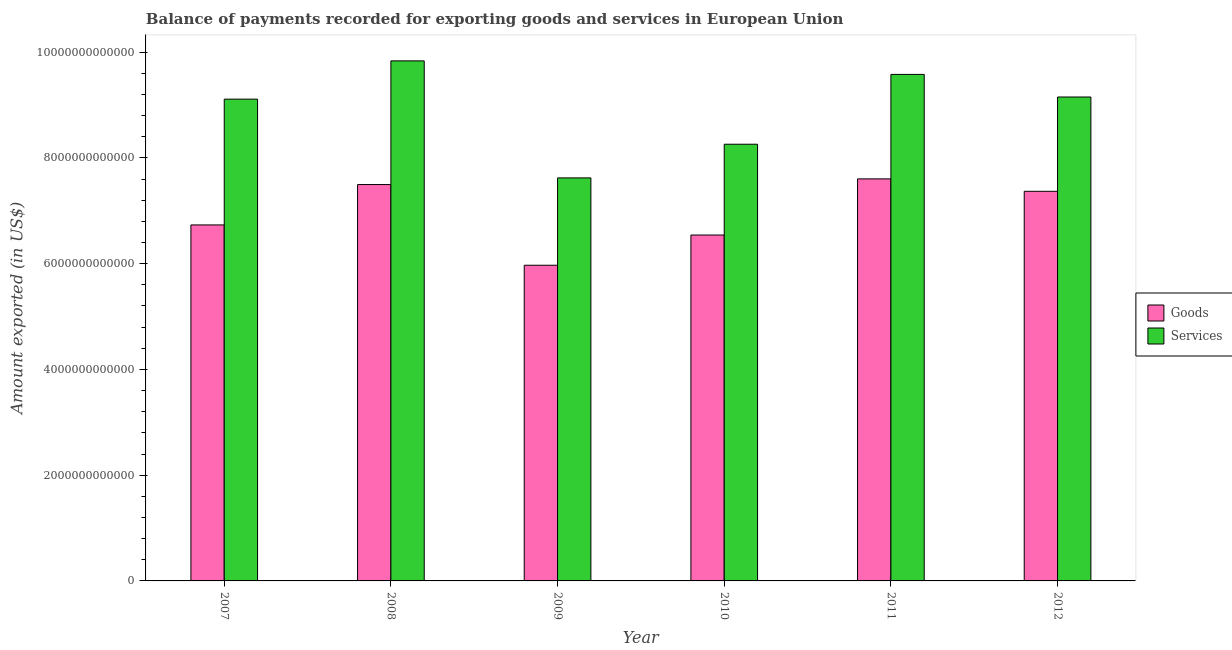How many groups of bars are there?
Ensure brevity in your answer.  6. Are the number of bars per tick equal to the number of legend labels?
Offer a very short reply. Yes. Are the number of bars on each tick of the X-axis equal?
Keep it short and to the point. Yes. What is the amount of goods exported in 2008?
Make the answer very short. 7.50e+12. Across all years, what is the maximum amount of services exported?
Ensure brevity in your answer.  9.84e+12. Across all years, what is the minimum amount of services exported?
Provide a short and direct response. 7.62e+12. In which year was the amount of services exported minimum?
Provide a succinct answer. 2009. What is the total amount of services exported in the graph?
Offer a terse response. 5.36e+13. What is the difference between the amount of services exported in 2007 and that in 2010?
Ensure brevity in your answer.  8.53e+11. What is the difference between the amount of services exported in 2011 and the amount of goods exported in 2007?
Ensure brevity in your answer.  4.68e+11. What is the average amount of goods exported per year?
Provide a short and direct response. 6.95e+12. What is the ratio of the amount of services exported in 2008 to that in 2009?
Offer a terse response. 1.29. What is the difference between the highest and the second highest amount of services exported?
Provide a succinct answer. 2.56e+11. What is the difference between the highest and the lowest amount of services exported?
Provide a succinct answer. 2.21e+12. In how many years, is the amount of services exported greater than the average amount of services exported taken over all years?
Provide a short and direct response. 4. What does the 1st bar from the left in 2007 represents?
Make the answer very short. Goods. What does the 1st bar from the right in 2010 represents?
Keep it short and to the point. Services. Are all the bars in the graph horizontal?
Give a very brief answer. No. How many years are there in the graph?
Your answer should be compact. 6. What is the difference between two consecutive major ticks on the Y-axis?
Make the answer very short. 2.00e+12. Does the graph contain any zero values?
Give a very brief answer. No. How many legend labels are there?
Your answer should be very brief. 2. How are the legend labels stacked?
Offer a very short reply. Vertical. What is the title of the graph?
Your answer should be compact. Balance of payments recorded for exporting goods and services in European Union. What is the label or title of the X-axis?
Your answer should be very brief. Year. What is the label or title of the Y-axis?
Provide a succinct answer. Amount exported (in US$). What is the Amount exported (in US$) of Goods in 2007?
Offer a terse response. 6.73e+12. What is the Amount exported (in US$) of Services in 2007?
Provide a short and direct response. 9.11e+12. What is the Amount exported (in US$) in Goods in 2008?
Provide a short and direct response. 7.50e+12. What is the Amount exported (in US$) of Services in 2008?
Provide a succinct answer. 9.84e+12. What is the Amount exported (in US$) of Goods in 2009?
Provide a short and direct response. 5.97e+12. What is the Amount exported (in US$) in Services in 2009?
Your response must be concise. 7.62e+12. What is the Amount exported (in US$) in Goods in 2010?
Your response must be concise. 6.54e+12. What is the Amount exported (in US$) in Services in 2010?
Give a very brief answer. 8.26e+12. What is the Amount exported (in US$) of Goods in 2011?
Your answer should be compact. 7.60e+12. What is the Amount exported (in US$) of Services in 2011?
Offer a very short reply. 9.58e+12. What is the Amount exported (in US$) of Goods in 2012?
Keep it short and to the point. 7.37e+12. What is the Amount exported (in US$) of Services in 2012?
Make the answer very short. 9.15e+12. Across all years, what is the maximum Amount exported (in US$) in Goods?
Offer a terse response. 7.60e+12. Across all years, what is the maximum Amount exported (in US$) of Services?
Give a very brief answer. 9.84e+12. Across all years, what is the minimum Amount exported (in US$) in Goods?
Provide a short and direct response. 5.97e+12. Across all years, what is the minimum Amount exported (in US$) in Services?
Keep it short and to the point. 7.62e+12. What is the total Amount exported (in US$) in Goods in the graph?
Keep it short and to the point. 4.17e+13. What is the total Amount exported (in US$) of Services in the graph?
Ensure brevity in your answer.  5.36e+13. What is the difference between the Amount exported (in US$) in Goods in 2007 and that in 2008?
Make the answer very short. -7.64e+11. What is the difference between the Amount exported (in US$) in Services in 2007 and that in 2008?
Give a very brief answer. -7.24e+11. What is the difference between the Amount exported (in US$) in Goods in 2007 and that in 2009?
Your answer should be compact. 7.62e+11. What is the difference between the Amount exported (in US$) in Services in 2007 and that in 2009?
Give a very brief answer. 1.49e+12. What is the difference between the Amount exported (in US$) of Goods in 2007 and that in 2010?
Ensure brevity in your answer.  1.91e+11. What is the difference between the Amount exported (in US$) of Services in 2007 and that in 2010?
Your answer should be compact. 8.53e+11. What is the difference between the Amount exported (in US$) in Goods in 2007 and that in 2011?
Make the answer very short. -8.71e+11. What is the difference between the Amount exported (in US$) in Services in 2007 and that in 2011?
Ensure brevity in your answer.  -4.68e+11. What is the difference between the Amount exported (in US$) in Goods in 2007 and that in 2012?
Your response must be concise. -6.36e+11. What is the difference between the Amount exported (in US$) of Services in 2007 and that in 2012?
Offer a very short reply. -4.03e+1. What is the difference between the Amount exported (in US$) of Goods in 2008 and that in 2009?
Your answer should be very brief. 1.53e+12. What is the difference between the Amount exported (in US$) of Services in 2008 and that in 2009?
Give a very brief answer. 2.21e+12. What is the difference between the Amount exported (in US$) of Goods in 2008 and that in 2010?
Provide a short and direct response. 9.54e+11. What is the difference between the Amount exported (in US$) of Services in 2008 and that in 2010?
Your answer should be very brief. 1.58e+12. What is the difference between the Amount exported (in US$) in Goods in 2008 and that in 2011?
Your answer should be very brief. -1.07e+11. What is the difference between the Amount exported (in US$) in Services in 2008 and that in 2011?
Keep it short and to the point. 2.56e+11. What is the difference between the Amount exported (in US$) of Goods in 2008 and that in 2012?
Your answer should be compact. 1.28e+11. What is the difference between the Amount exported (in US$) of Services in 2008 and that in 2012?
Your answer should be very brief. 6.83e+11. What is the difference between the Amount exported (in US$) in Goods in 2009 and that in 2010?
Offer a very short reply. -5.71e+11. What is the difference between the Amount exported (in US$) of Services in 2009 and that in 2010?
Make the answer very short. -6.37e+11. What is the difference between the Amount exported (in US$) in Goods in 2009 and that in 2011?
Provide a short and direct response. -1.63e+12. What is the difference between the Amount exported (in US$) of Services in 2009 and that in 2011?
Your answer should be very brief. -1.96e+12. What is the difference between the Amount exported (in US$) of Goods in 2009 and that in 2012?
Offer a very short reply. -1.40e+12. What is the difference between the Amount exported (in US$) of Services in 2009 and that in 2012?
Provide a succinct answer. -1.53e+12. What is the difference between the Amount exported (in US$) of Goods in 2010 and that in 2011?
Ensure brevity in your answer.  -1.06e+12. What is the difference between the Amount exported (in US$) in Services in 2010 and that in 2011?
Your response must be concise. -1.32e+12. What is the difference between the Amount exported (in US$) in Goods in 2010 and that in 2012?
Keep it short and to the point. -8.27e+11. What is the difference between the Amount exported (in US$) in Services in 2010 and that in 2012?
Keep it short and to the point. -8.93e+11. What is the difference between the Amount exported (in US$) in Goods in 2011 and that in 2012?
Provide a succinct answer. 2.35e+11. What is the difference between the Amount exported (in US$) in Services in 2011 and that in 2012?
Make the answer very short. 4.28e+11. What is the difference between the Amount exported (in US$) in Goods in 2007 and the Amount exported (in US$) in Services in 2008?
Ensure brevity in your answer.  -3.10e+12. What is the difference between the Amount exported (in US$) in Goods in 2007 and the Amount exported (in US$) in Services in 2009?
Keep it short and to the point. -8.89e+11. What is the difference between the Amount exported (in US$) of Goods in 2007 and the Amount exported (in US$) of Services in 2010?
Keep it short and to the point. -1.53e+12. What is the difference between the Amount exported (in US$) of Goods in 2007 and the Amount exported (in US$) of Services in 2011?
Your answer should be very brief. -2.85e+12. What is the difference between the Amount exported (in US$) of Goods in 2007 and the Amount exported (in US$) of Services in 2012?
Offer a terse response. -2.42e+12. What is the difference between the Amount exported (in US$) in Goods in 2008 and the Amount exported (in US$) in Services in 2009?
Provide a short and direct response. -1.26e+11. What is the difference between the Amount exported (in US$) of Goods in 2008 and the Amount exported (in US$) of Services in 2010?
Your answer should be very brief. -7.63e+11. What is the difference between the Amount exported (in US$) in Goods in 2008 and the Amount exported (in US$) in Services in 2011?
Keep it short and to the point. -2.08e+12. What is the difference between the Amount exported (in US$) in Goods in 2008 and the Amount exported (in US$) in Services in 2012?
Keep it short and to the point. -1.66e+12. What is the difference between the Amount exported (in US$) of Goods in 2009 and the Amount exported (in US$) of Services in 2010?
Your answer should be very brief. -2.29e+12. What is the difference between the Amount exported (in US$) in Goods in 2009 and the Amount exported (in US$) in Services in 2011?
Ensure brevity in your answer.  -3.61e+12. What is the difference between the Amount exported (in US$) of Goods in 2009 and the Amount exported (in US$) of Services in 2012?
Your answer should be compact. -3.18e+12. What is the difference between the Amount exported (in US$) in Goods in 2010 and the Amount exported (in US$) in Services in 2011?
Give a very brief answer. -3.04e+12. What is the difference between the Amount exported (in US$) in Goods in 2010 and the Amount exported (in US$) in Services in 2012?
Give a very brief answer. -2.61e+12. What is the difference between the Amount exported (in US$) of Goods in 2011 and the Amount exported (in US$) of Services in 2012?
Provide a succinct answer. -1.55e+12. What is the average Amount exported (in US$) in Goods per year?
Give a very brief answer. 6.95e+12. What is the average Amount exported (in US$) in Services per year?
Give a very brief answer. 8.93e+12. In the year 2007, what is the difference between the Amount exported (in US$) in Goods and Amount exported (in US$) in Services?
Offer a very short reply. -2.38e+12. In the year 2008, what is the difference between the Amount exported (in US$) in Goods and Amount exported (in US$) in Services?
Your answer should be compact. -2.34e+12. In the year 2009, what is the difference between the Amount exported (in US$) of Goods and Amount exported (in US$) of Services?
Ensure brevity in your answer.  -1.65e+12. In the year 2010, what is the difference between the Amount exported (in US$) in Goods and Amount exported (in US$) in Services?
Make the answer very short. -1.72e+12. In the year 2011, what is the difference between the Amount exported (in US$) in Goods and Amount exported (in US$) in Services?
Your answer should be very brief. -1.98e+12. In the year 2012, what is the difference between the Amount exported (in US$) of Goods and Amount exported (in US$) of Services?
Your response must be concise. -1.78e+12. What is the ratio of the Amount exported (in US$) in Goods in 2007 to that in 2008?
Your answer should be very brief. 0.9. What is the ratio of the Amount exported (in US$) of Services in 2007 to that in 2008?
Offer a very short reply. 0.93. What is the ratio of the Amount exported (in US$) in Goods in 2007 to that in 2009?
Offer a very short reply. 1.13. What is the ratio of the Amount exported (in US$) in Services in 2007 to that in 2009?
Your answer should be very brief. 1.2. What is the ratio of the Amount exported (in US$) of Goods in 2007 to that in 2010?
Provide a succinct answer. 1.03. What is the ratio of the Amount exported (in US$) in Services in 2007 to that in 2010?
Ensure brevity in your answer.  1.1. What is the ratio of the Amount exported (in US$) in Goods in 2007 to that in 2011?
Give a very brief answer. 0.89. What is the ratio of the Amount exported (in US$) in Services in 2007 to that in 2011?
Ensure brevity in your answer.  0.95. What is the ratio of the Amount exported (in US$) in Goods in 2007 to that in 2012?
Your answer should be very brief. 0.91. What is the ratio of the Amount exported (in US$) of Services in 2007 to that in 2012?
Your answer should be compact. 1. What is the ratio of the Amount exported (in US$) in Goods in 2008 to that in 2009?
Your response must be concise. 1.26. What is the ratio of the Amount exported (in US$) in Services in 2008 to that in 2009?
Your response must be concise. 1.29. What is the ratio of the Amount exported (in US$) of Goods in 2008 to that in 2010?
Provide a succinct answer. 1.15. What is the ratio of the Amount exported (in US$) of Services in 2008 to that in 2010?
Your response must be concise. 1.19. What is the ratio of the Amount exported (in US$) in Goods in 2008 to that in 2011?
Your answer should be compact. 0.99. What is the ratio of the Amount exported (in US$) in Services in 2008 to that in 2011?
Provide a succinct answer. 1.03. What is the ratio of the Amount exported (in US$) of Goods in 2008 to that in 2012?
Make the answer very short. 1.02. What is the ratio of the Amount exported (in US$) of Services in 2008 to that in 2012?
Give a very brief answer. 1.07. What is the ratio of the Amount exported (in US$) of Goods in 2009 to that in 2010?
Provide a short and direct response. 0.91. What is the ratio of the Amount exported (in US$) of Services in 2009 to that in 2010?
Provide a short and direct response. 0.92. What is the ratio of the Amount exported (in US$) of Goods in 2009 to that in 2011?
Make the answer very short. 0.79. What is the ratio of the Amount exported (in US$) in Services in 2009 to that in 2011?
Offer a very short reply. 0.8. What is the ratio of the Amount exported (in US$) of Goods in 2009 to that in 2012?
Your answer should be very brief. 0.81. What is the ratio of the Amount exported (in US$) in Services in 2009 to that in 2012?
Offer a very short reply. 0.83. What is the ratio of the Amount exported (in US$) of Goods in 2010 to that in 2011?
Provide a short and direct response. 0.86. What is the ratio of the Amount exported (in US$) of Services in 2010 to that in 2011?
Ensure brevity in your answer.  0.86. What is the ratio of the Amount exported (in US$) of Goods in 2010 to that in 2012?
Offer a very short reply. 0.89. What is the ratio of the Amount exported (in US$) of Services in 2010 to that in 2012?
Give a very brief answer. 0.9. What is the ratio of the Amount exported (in US$) of Goods in 2011 to that in 2012?
Offer a very short reply. 1.03. What is the ratio of the Amount exported (in US$) of Services in 2011 to that in 2012?
Your answer should be very brief. 1.05. What is the difference between the highest and the second highest Amount exported (in US$) in Goods?
Give a very brief answer. 1.07e+11. What is the difference between the highest and the second highest Amount exported (in US$) of Services?
Provide a short and direct response. 2.56e+11. What is the difference between the highest and the lowest Amount exported (in US$) of Goods?
Your response must be concise. 1.63e+12. What is the difference between the highest and the lowest Amount exported (in US$) in Services?
Provide a succinct answer. 2.21e+12. 